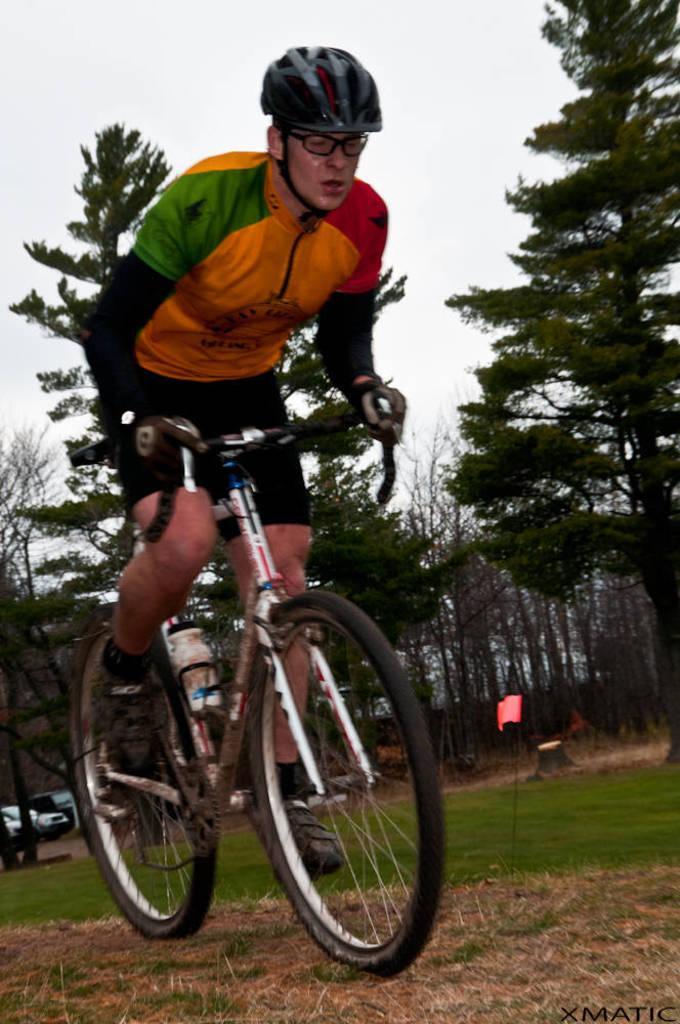How would you summarize this image in a sentence or two? This image consists of a man riding a bicycle. At the bottom, there is green grass. In the background, there are many trees. On the left, there are cars parked on the ground. At the top, there is sky. 